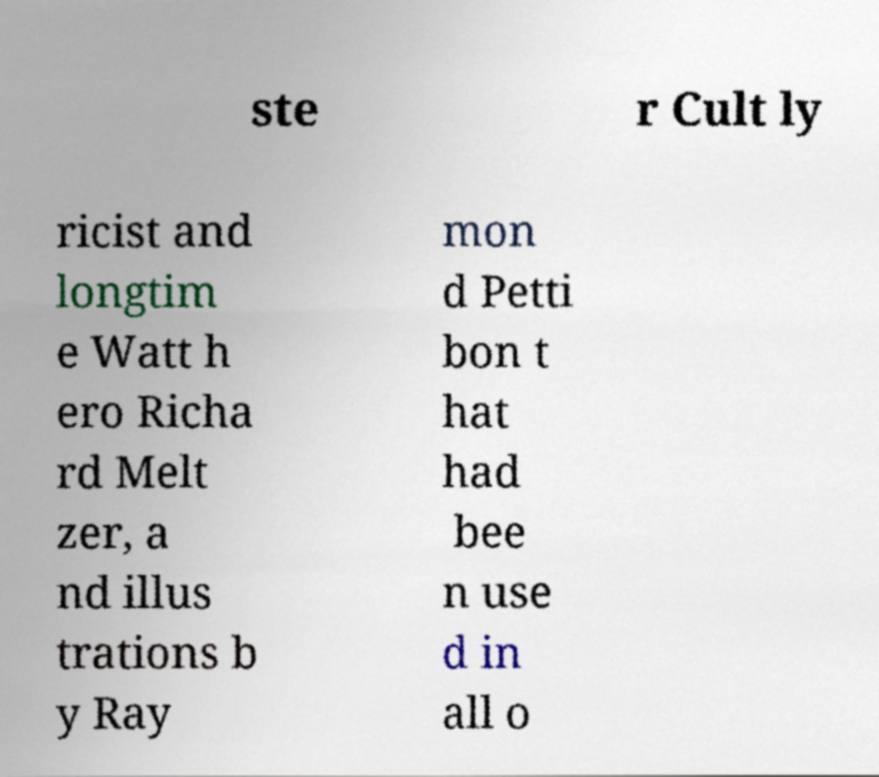I need the written content from this picture converted into text. Can you do that? ste r Cult ly ricist and longtim e Watt h ero Richa rd Melt zer, a nd illus trations b y Ray mon d Petti bon t hat had bee n use d in all o 